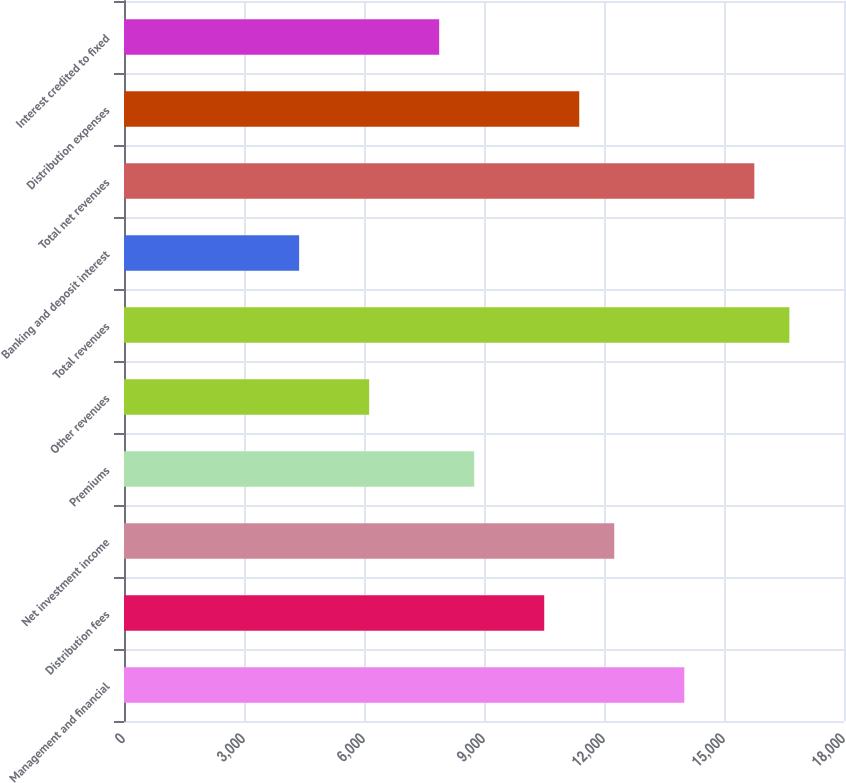Convert chart to OTSL. <chart><loc_0><loc_0><loc_500><loc_500><bar_chart><fcel>Management and financial<fcel>Distribution fees<fcel>Net investment income<fcel>Premiums<fcel>Other revenues<fcel>Total revenues<fcel>Banking and deposit interest<fcel>Total net revenues<fcel>Distribution expenses<fcel>Interest credited to fixed<nl><fcel>14007.6<fcel>10505.8<fcel>12256.7<fcel>8754.96<fcel>6128.64<fcel>16633.9<fcel>4377.76<fcel>15758.5<fcel>11381.3<fcel>7879.52<nl></chart> 